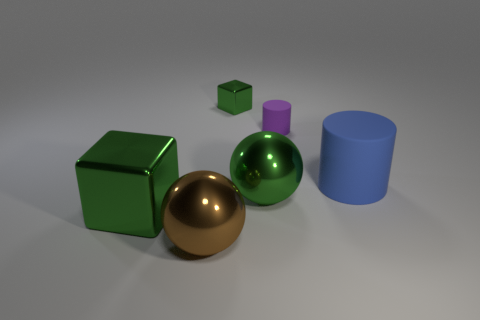Are there any big cubes on the left side of the green metal sphere?
Your response must be concise. Yes. The brown metal object that is the same size as the green ball is what shape?
Offer a very short reply. Sphere. Is the material of the small green object the same as the tiny cylinder?
Offer a terse response. No. How many matte objects are large things or large brown balls?
Your answer should be compact. 1. What is the shape of the big object that is the same color as the large cube?
Your response must be concise. Sphere. Is the color of the metal ball that is to the left of the small green cube the same as the tiny cylinder?
Give a very brief answer. No. The green thing on the right side of the tiny green metallic block behind the large cube is what shape?
Offer a terse response. Sphere. What number of objects are large things behind the big brown object or purple cylinders on the left side of the large blue cylinder?
Offer a terse response. 4. There is a brown object that is made of the same material as the big cube; what shape is it?
Offer a terse response. Sphere. Is there anything else of the same color as the tiny metallic cube?
Your answer should be very brief. Yes. 